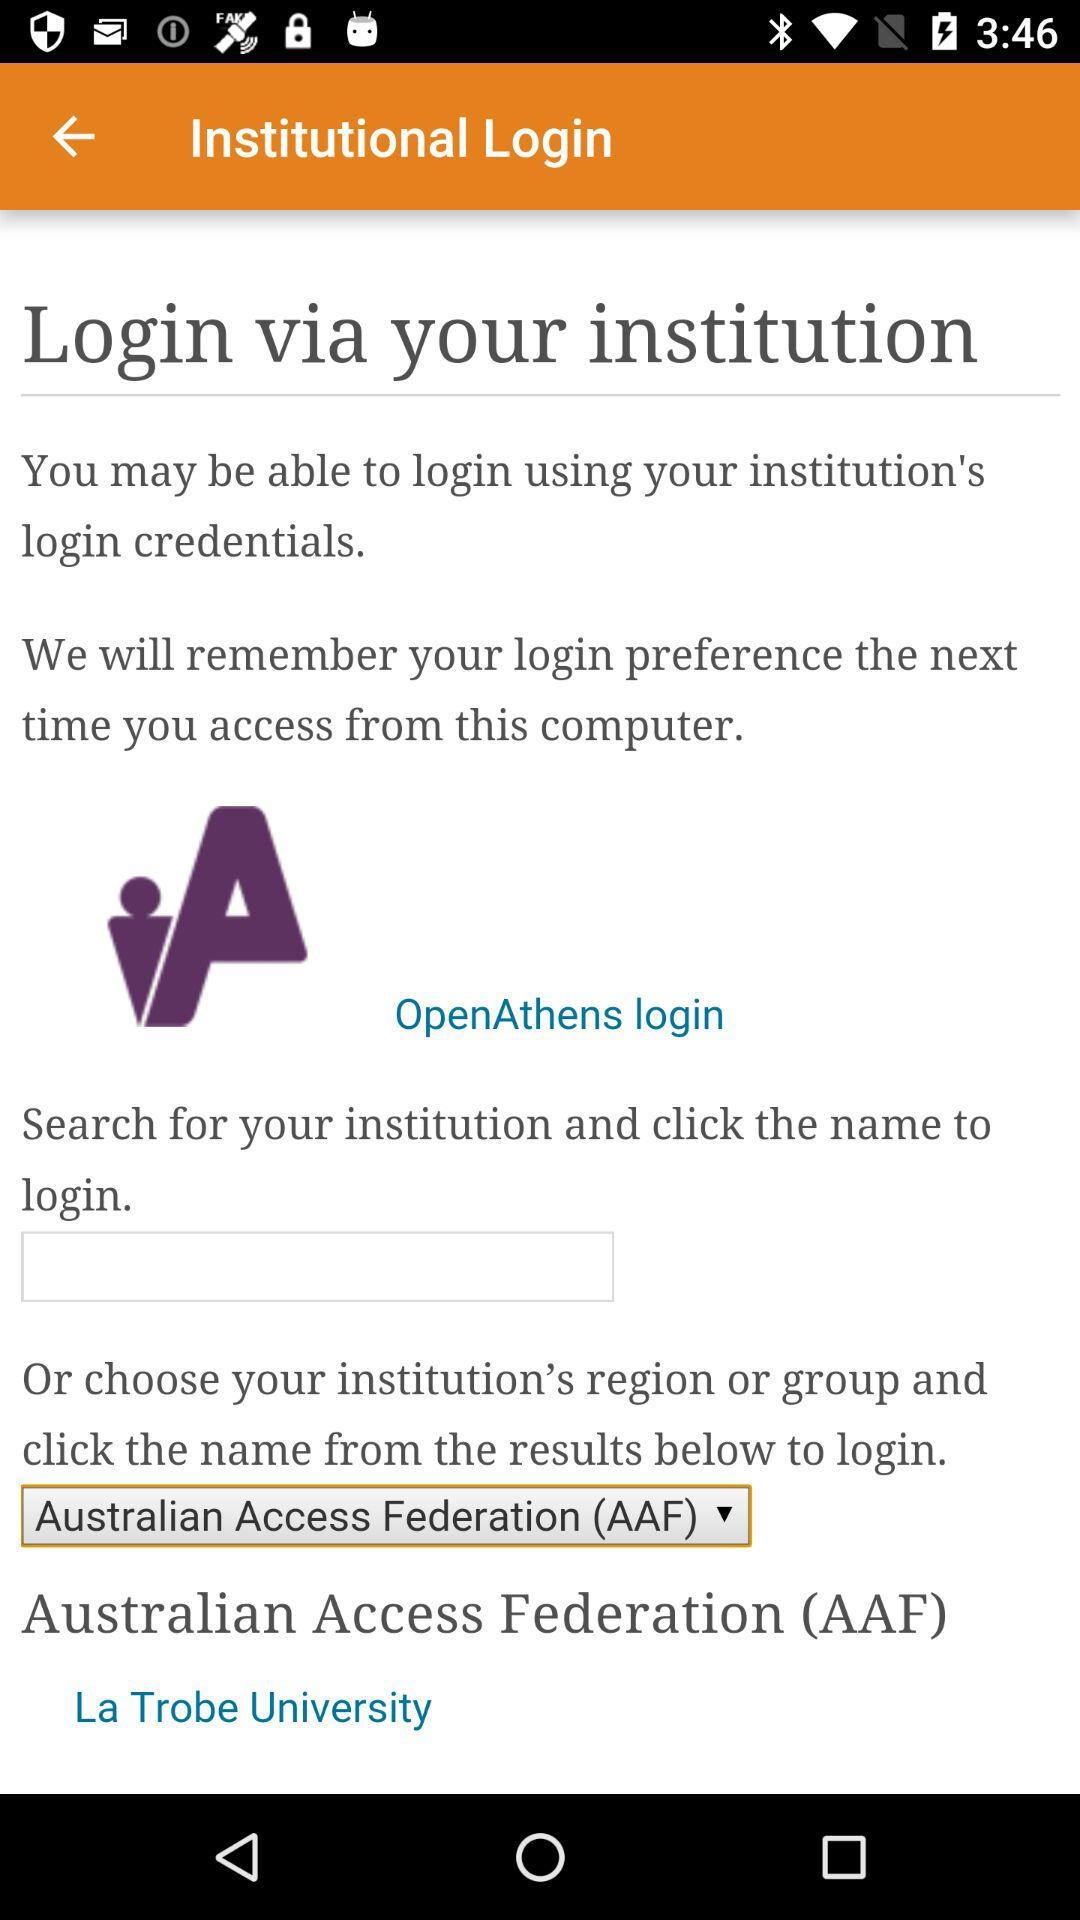What is the name of the selected institution? The name of the selected institution is "Australian Access Federation (AAF)". 